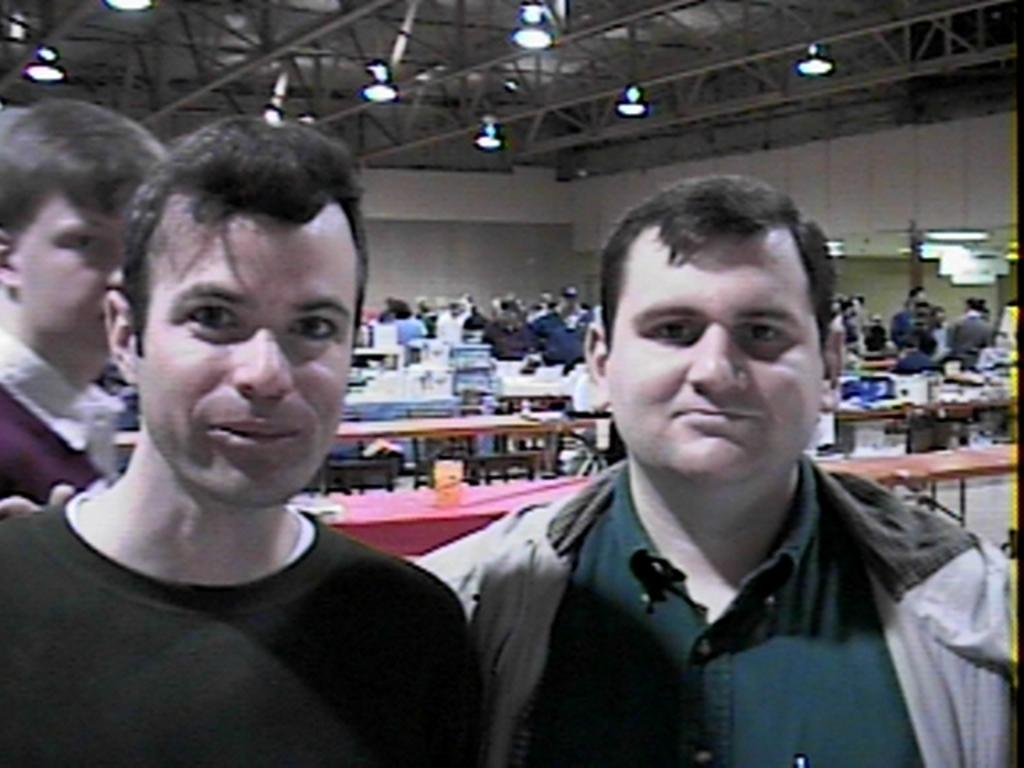Who or what can be seen in the image? There are people in the image. What can be seen in the background of the image? There are benches, a group of people standing, a wall, and a roof with ceiling lights in the background. Can you describe the setting of the image? The image appears to be set in an outdoor or semi-enclosed area with benches and a wall, possibly a courtyard or a covered patio. What type of knife is being used by the people in the image? There is no knife present in the image; the people are not using any tools or utensils. 